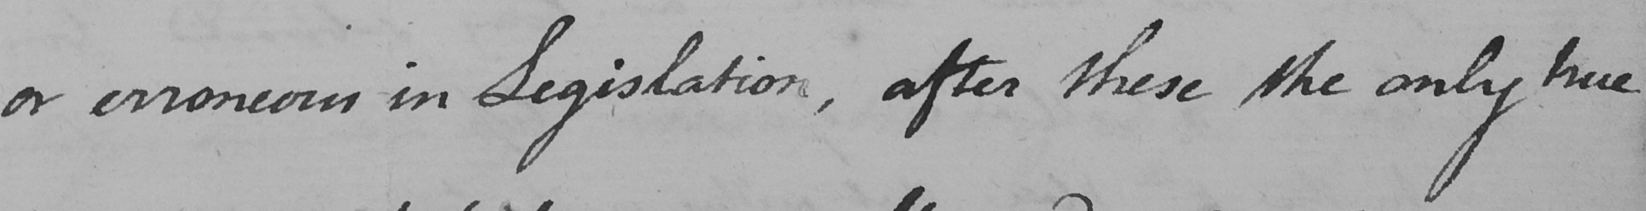What is written in this line of handwriting? or erroneous in Legislation , after these the only true 